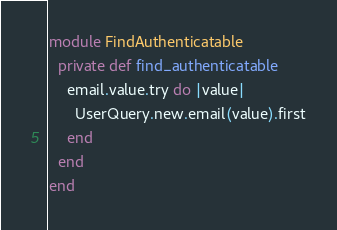Convert code to text. <code><loc_0><loc_0><loc_500><loc_500><_Crystal_>module FindAuthenticatable
  private def find_authenticatable
    email.value.try do |value|
      UserQuery.new.email(value).first
    end
  end
end
</code> 